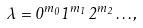<formula> <loc_0><loc_0><loc_500><loc_500>\lambda = 0 ^ { m _ { 0 } } 1 ^ { m _ { 1 } } 2 ^ { m _ { 2 } } \dots ,</formula> 